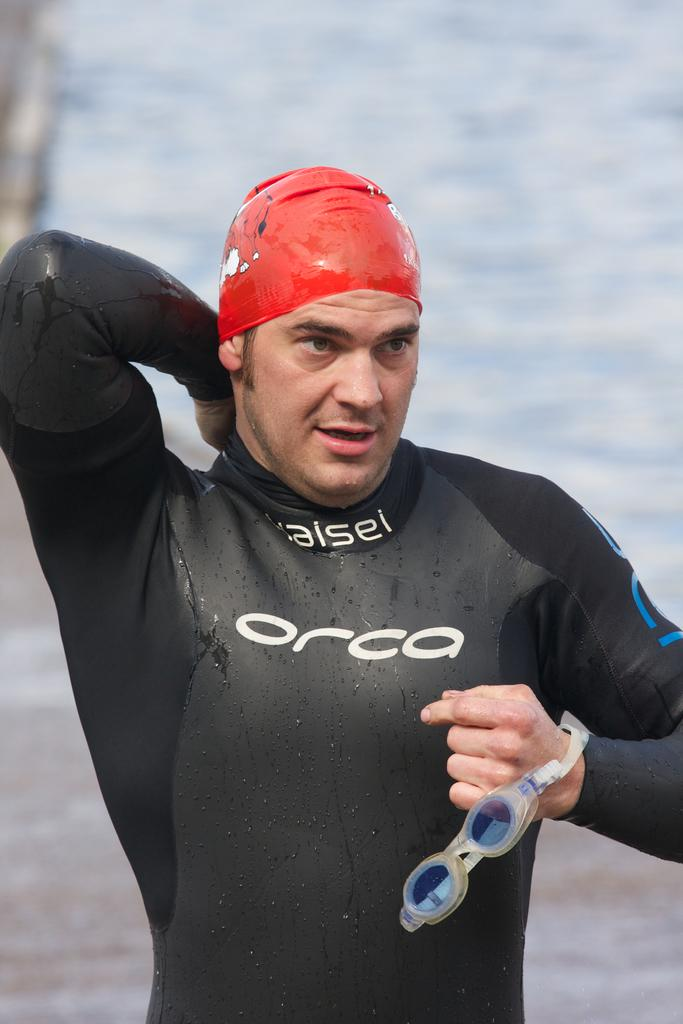What can be seen in the image? There is a person in the image. What is the person wearing? The person is wearing a black color swimsuit and a red color cap on his head. What is the background of the image? There is water visible in the background of the image. What type of body modification can be seen on the person's hair in the image? There is no body modification visible on the person's hair in the image. What kind of haircut does the person have in the image? The person's hair is covered by the red color cap, so it is not possible to determine the type of haircut. 